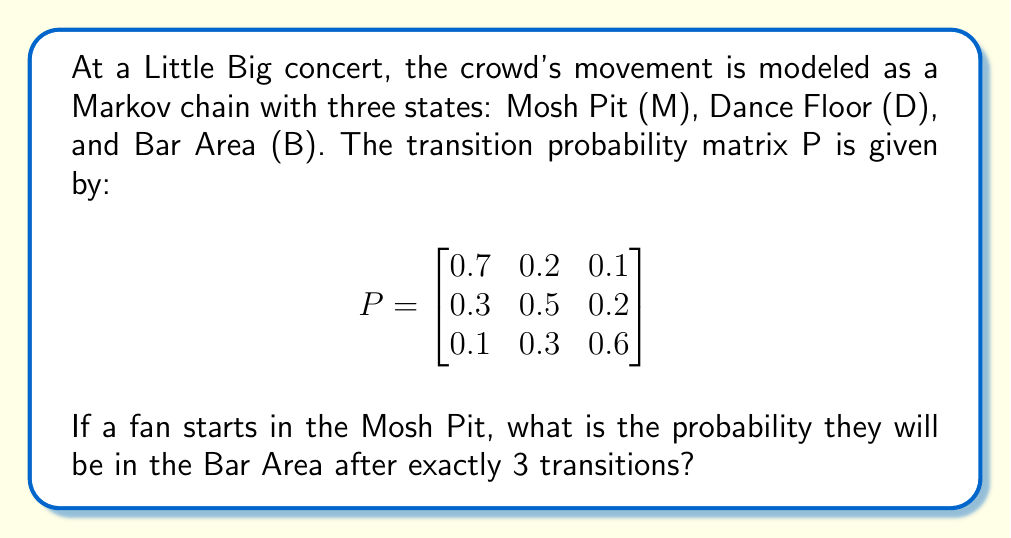What is the answer to this math problem? To solve this problem, we need to calculate $P^3$ and look at the entry in the first row, third column. This represents the probability of moving from the Mosh Pit (M) to the Bar Area (B) in exactly 3 steps.

Step 1: Calculate $P^2$
$$P^2 = P \cdot P = \begin{bmatrix}
0.56 & 0.27 & 0.17 \\
0.37 & 0.41 & 0.22 \\
0.22 & 0.36 & 0.42
\end{bmatrix}$$

Step 2: Calculate $P^3 = P \cdot P^2$
$$P^3 = \begin{bmatrix}
0.497 & 0.305 & 0.198 \\
0.389 & 0.371 & 0.240 \\
0.281 & 0.360 & 0.359
\end{bmatrix}$$

Step 3: The probability of being in the Bar Area (B) after 3 transitions, starting from the Mosh Pit (M), is the entry in the first row, third column of $P^3$, which is 0.198.
Answer: 0.198 